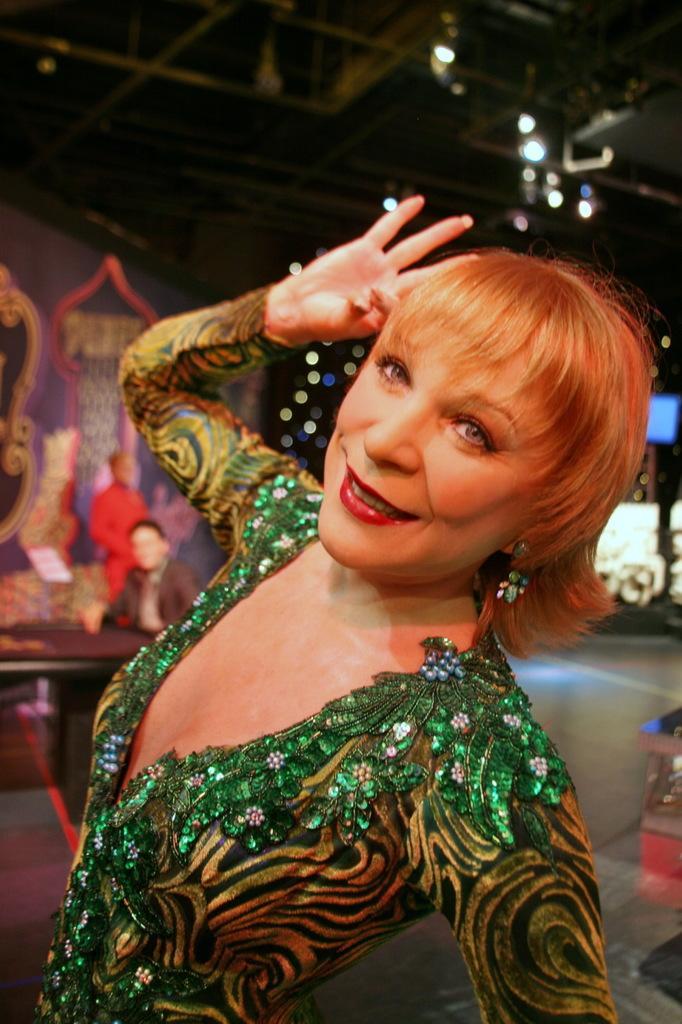Can you describe this image briefly? In the center of the image there is a lady smiling. She is wearing a green dress. In the background there are people and we can see a wall. At the top there are lights. 